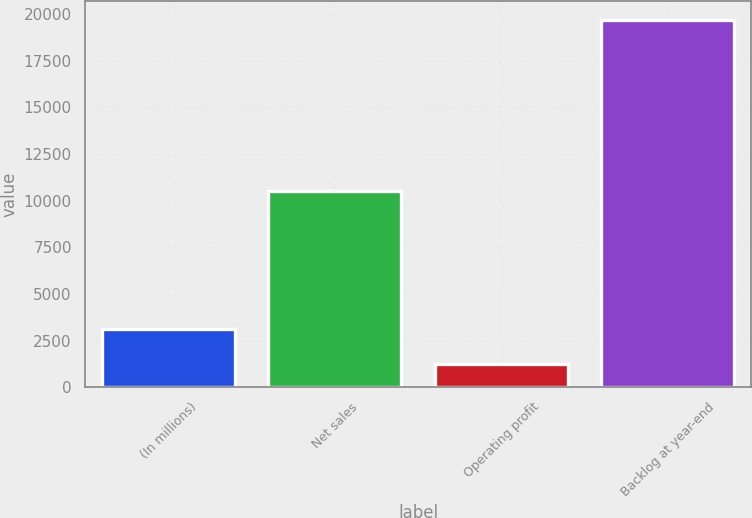<chart> <loc_0><loc_0><loc_500><loc_500><bar_chart><fcel>(In millions)<fcel>Net sales<fcel>Operating profit<fcel>Backlog at year-end<nl><fcel>3107.6<fcel>10519<fcel>1264<fcel>19700<nl></chart> 